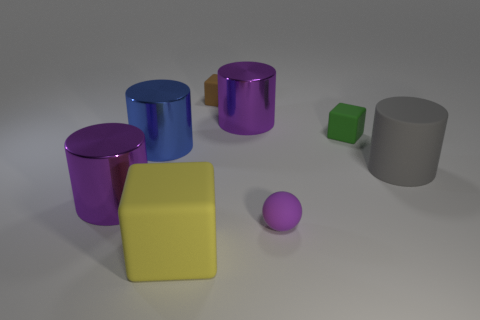Subtract all large rubber cylinders. How many cylinders are left? 3 Subtract all cyan cubes. How many purple cylinders are left? 2 Subtract all blue cylinders. How many cylinders are left? 3 Add 1 tiny blue rubber cubes. How many objects exist? 9 Subtract 2 cylinders. How many cylinders are left? 2 Subtract all cyan blocks. Subtract all red cylinders. How many blocks are left? 3 Subtract all spheres. How many objects are left? 7 Add 4 blocks. How many blocks exist? 7 Subtract 0 red cylinders. How many objects are left? 8 Subtract all big blue cylinders. Subtract all cylinders. How many objects are left? 3 